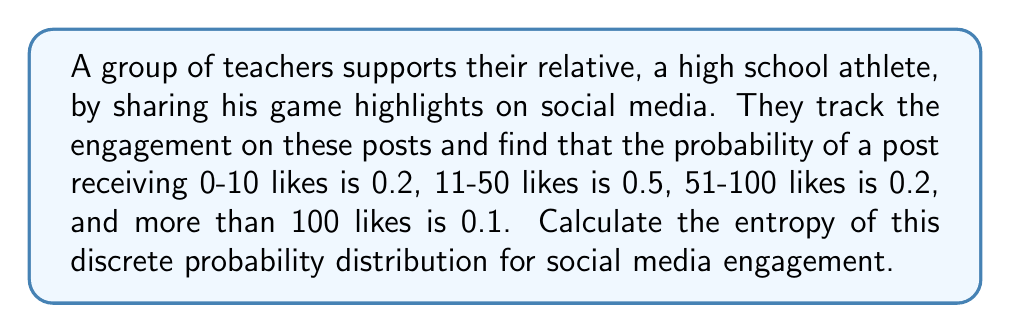Show me your answer to this math problem. To calculate the entropy of a discrete probability distribution, we use the formula:

$$H = -\sum_{i=1}^{n} p_i \log_2(p_i)$$

Where $H$ is the entropy, $p_i$ is the probability of each outcome, and $n$ is the number of possible outcomes.

Given probabilities:
$p_1 = 0.2$ (0-10 likes)
$p_2 = 0.5$ (11-50 likes)
$p_3 = 0.2$ (51-100 likes)
$p_4 = 0.1$ (more than 100 likes)

Let's calculate each term:

1) $-p_1 \log_2(p_1) = -0.2 \log_2(0.2) \approx 0.4644$
2) $-p_2 \log_2(p_2) = -0.5 \log_2(0.5) \approx 0.5$
3) $-p_3 \log_2(p_3) = -0.2 \log_2(0.2) \approx 0.4644$
4) $-p_4 \log_2(p_4) = -0.1 \log_2(0.1) \approx 0.3322$

Now, sum all these terms:

$$H = 0.4644 + 0.5 + 0.4644 + 0.3322 = 1.761$$

Therefore, the entropy of this discrete probability distribution is approximately 1.761 bits.
Answer: $H \approx 1.761$ bits 